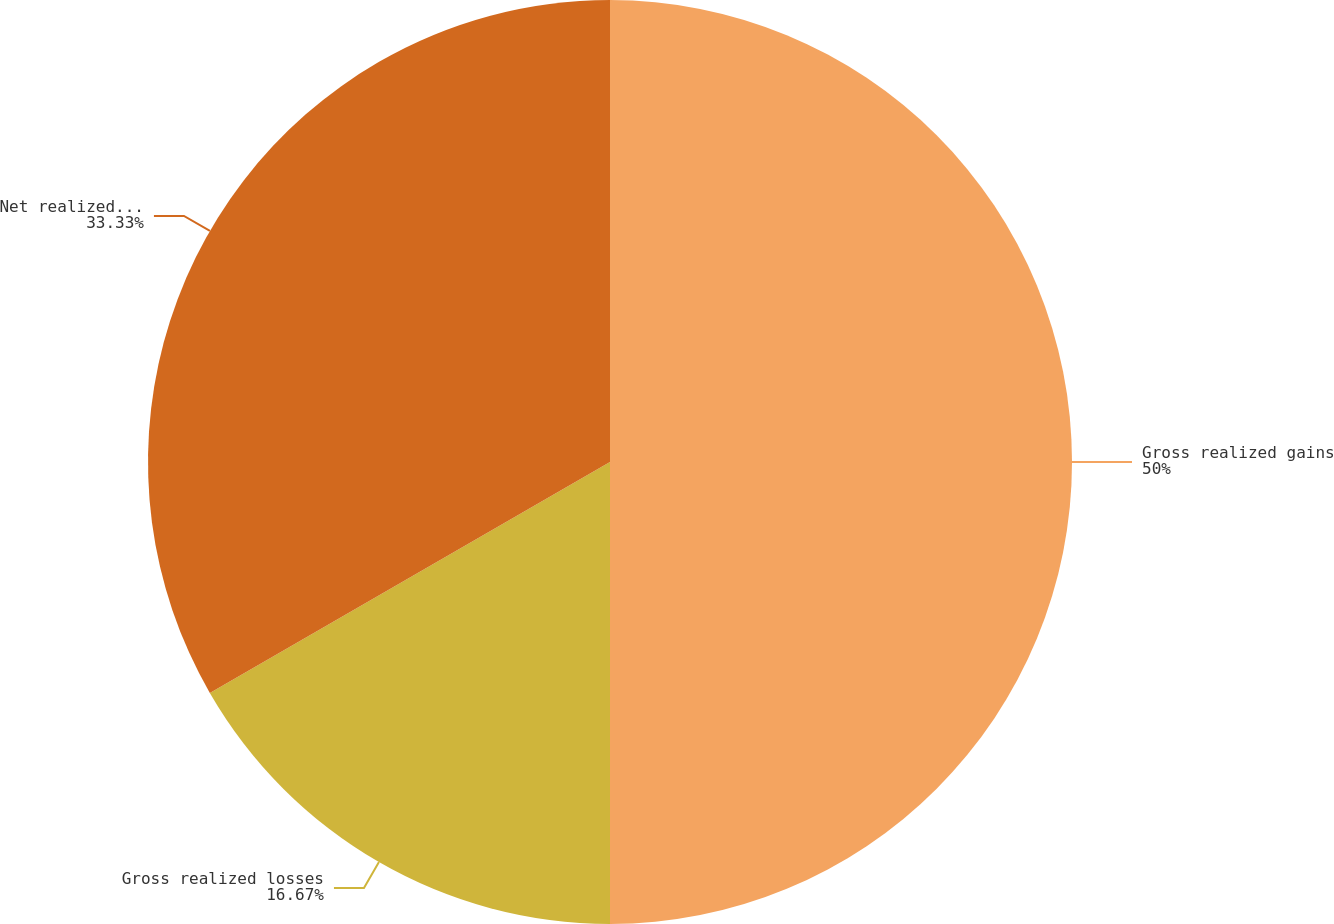Convert chart to OTSL. <chart><loc_0><loc_0><loc_500><loc_500><pie_chart><fcel>Gross realized gains<fcel>Gross realized losses<fcel>Net realized capital gains<nl><fcel>50.0%<fcel>16.67%<fcel>33.33%<nl></chart> 